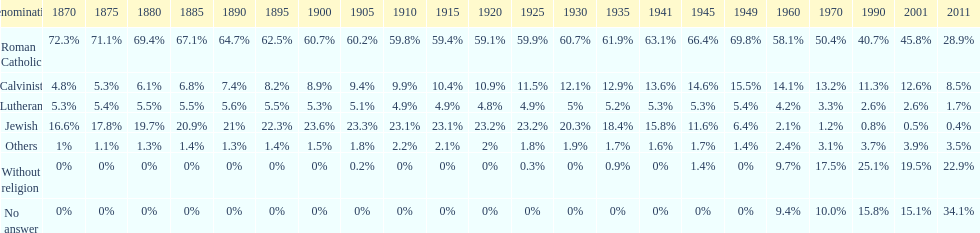Which religious denomination had a higher percentage in 1900, jewish or roman catholic? Roman Catholic. 